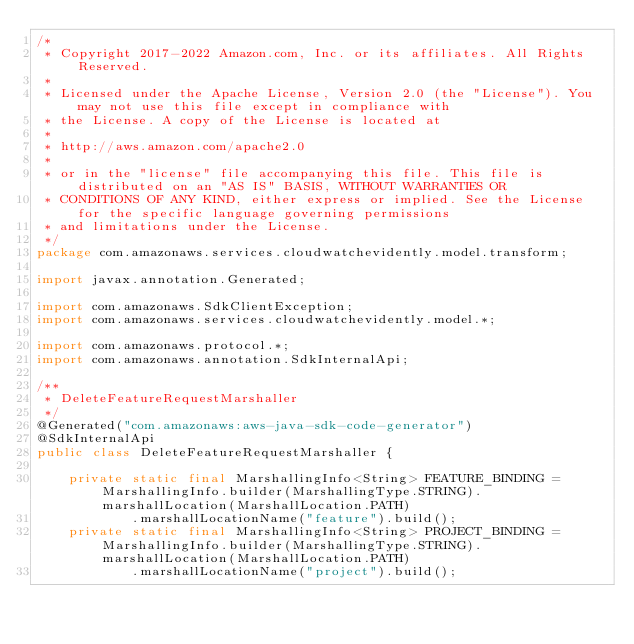<code> <loc_0><loc_0><loc_500><loc_500><_Java_>/*
 * Copyright 2017-2022 Amazon.com, Inc. or its affiliates. All Rights Reserved.
 * 
 * Licensed under the Apache License, Version 2.0 (the "License"). You may not use this file except in compliance with
 * the License. A copy of the License is located at
 * 
 * http://aws.amazon.com/apache2.0
 * 
 * or in the "license" file accompanying this file. This file is distributed on an "AS IS" BASIS, WITHOUT WARRANTIES OR
 * CONDITIONS OF ANY KIND, either express or implied. See the License for the specific language governing permissions
 * and limitations under the License.
 */
package com.amazonaws.services.cloudwatchevidently.model.transform;

import javax.annotation.Generated;

import com.amazonaws.SdkClientException;
import com.amazonaws.services.cloudwatchevidently.model.*;

import com.amazonaws.protocol.*;
import com.amazonaws.annotation.SdkInternalApi;

/**
 * DeleteFeatureRequestMarshaller
 */
@Generated("com.amazonaws:aws-java-sdk-code-generator")
@SdkInternalApi
public class DeleteFeatureRequestMarshaller {

    private static final MarshallingInfo<String> FEATURE_BINDING = MarshallingInfo.builder(MarshallingType.STRING).marshallLocation(MarshallLocation.PATH)
            .marshallLocationName("feature").build();
    private static final MarshallingInfo<String> PROJECT_BINDING = MarshallingInfo.builder(MarshallingType.STRING).marshallLocation(MarshallLocation.PATH)
            .marshallLocationName("project").build();
</code> 